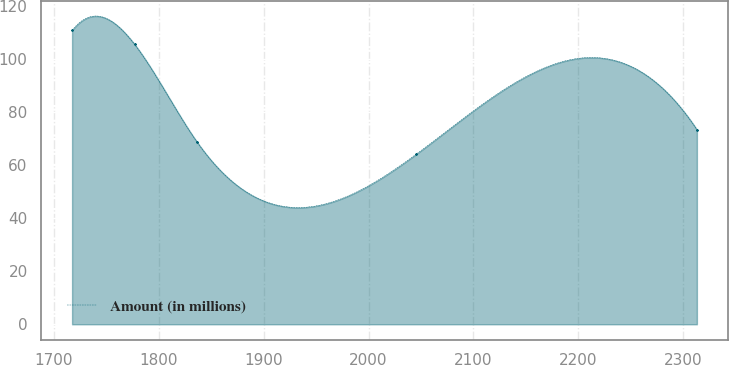<chart> <loc_0><loc_0><loc_500><loc_500><line_chart><ecel><fcel>Amount (in millions)<nl><fcel>1717.21<fcel>110.84<nl><fcel>1776.82<fcel>105.59<nl><fcel>1836.43<fcel>68.74<nl><fcel>2045.18<fcel>64.06<nl><fcel>2313.27<fcel>73.42<nl></chart> 